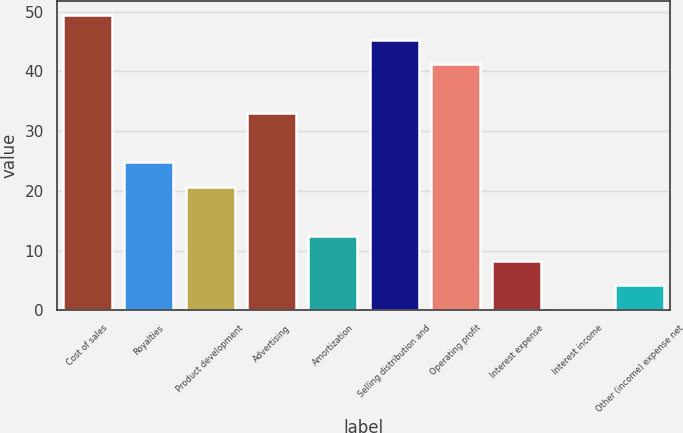Convert chart. <chart><loc_0><loc_0><loc_500><loc_500><bar_chart><fcel>Cost of sales<fcel>Royalties<fcel>Product development<fcel>Advertising<fcel>Amortization<fcel>Selling distribution and<fcel>Operating profit<fcel>Interest expense<fcel>Interest income<fcel>Other (income) expense net<nl><fcel>49.42<fcel>24.76<fcel>20.65<fcel>32.98<fcel>12.43<fcel>45.31<fcel>41.2<fcel>8.32<fcel>0.1<fcel>4.21<nl></chart> 